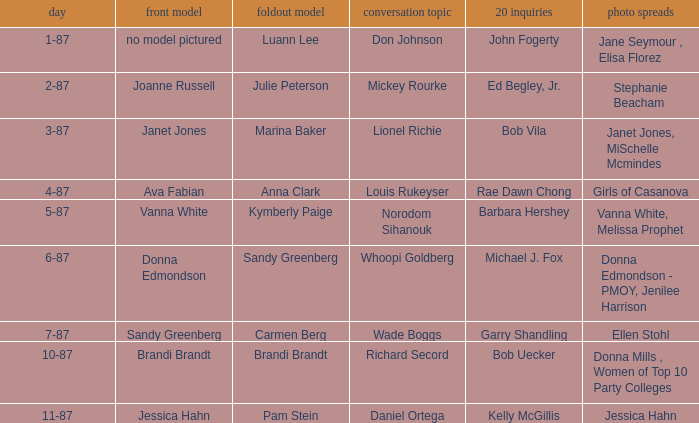When was the Kymberly Paige the Centerfold? 5-87. 